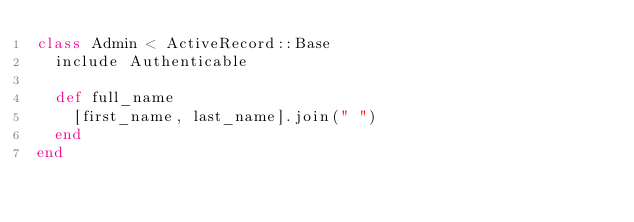<code> <loc_0><loc_0><loc_500><loc_500><_Ruby_>class Admin < ActiveRecord::Base
  include Authenticable
  
  def full_name
    [first_name, last_name].join(" ")
  end
end
</code> 